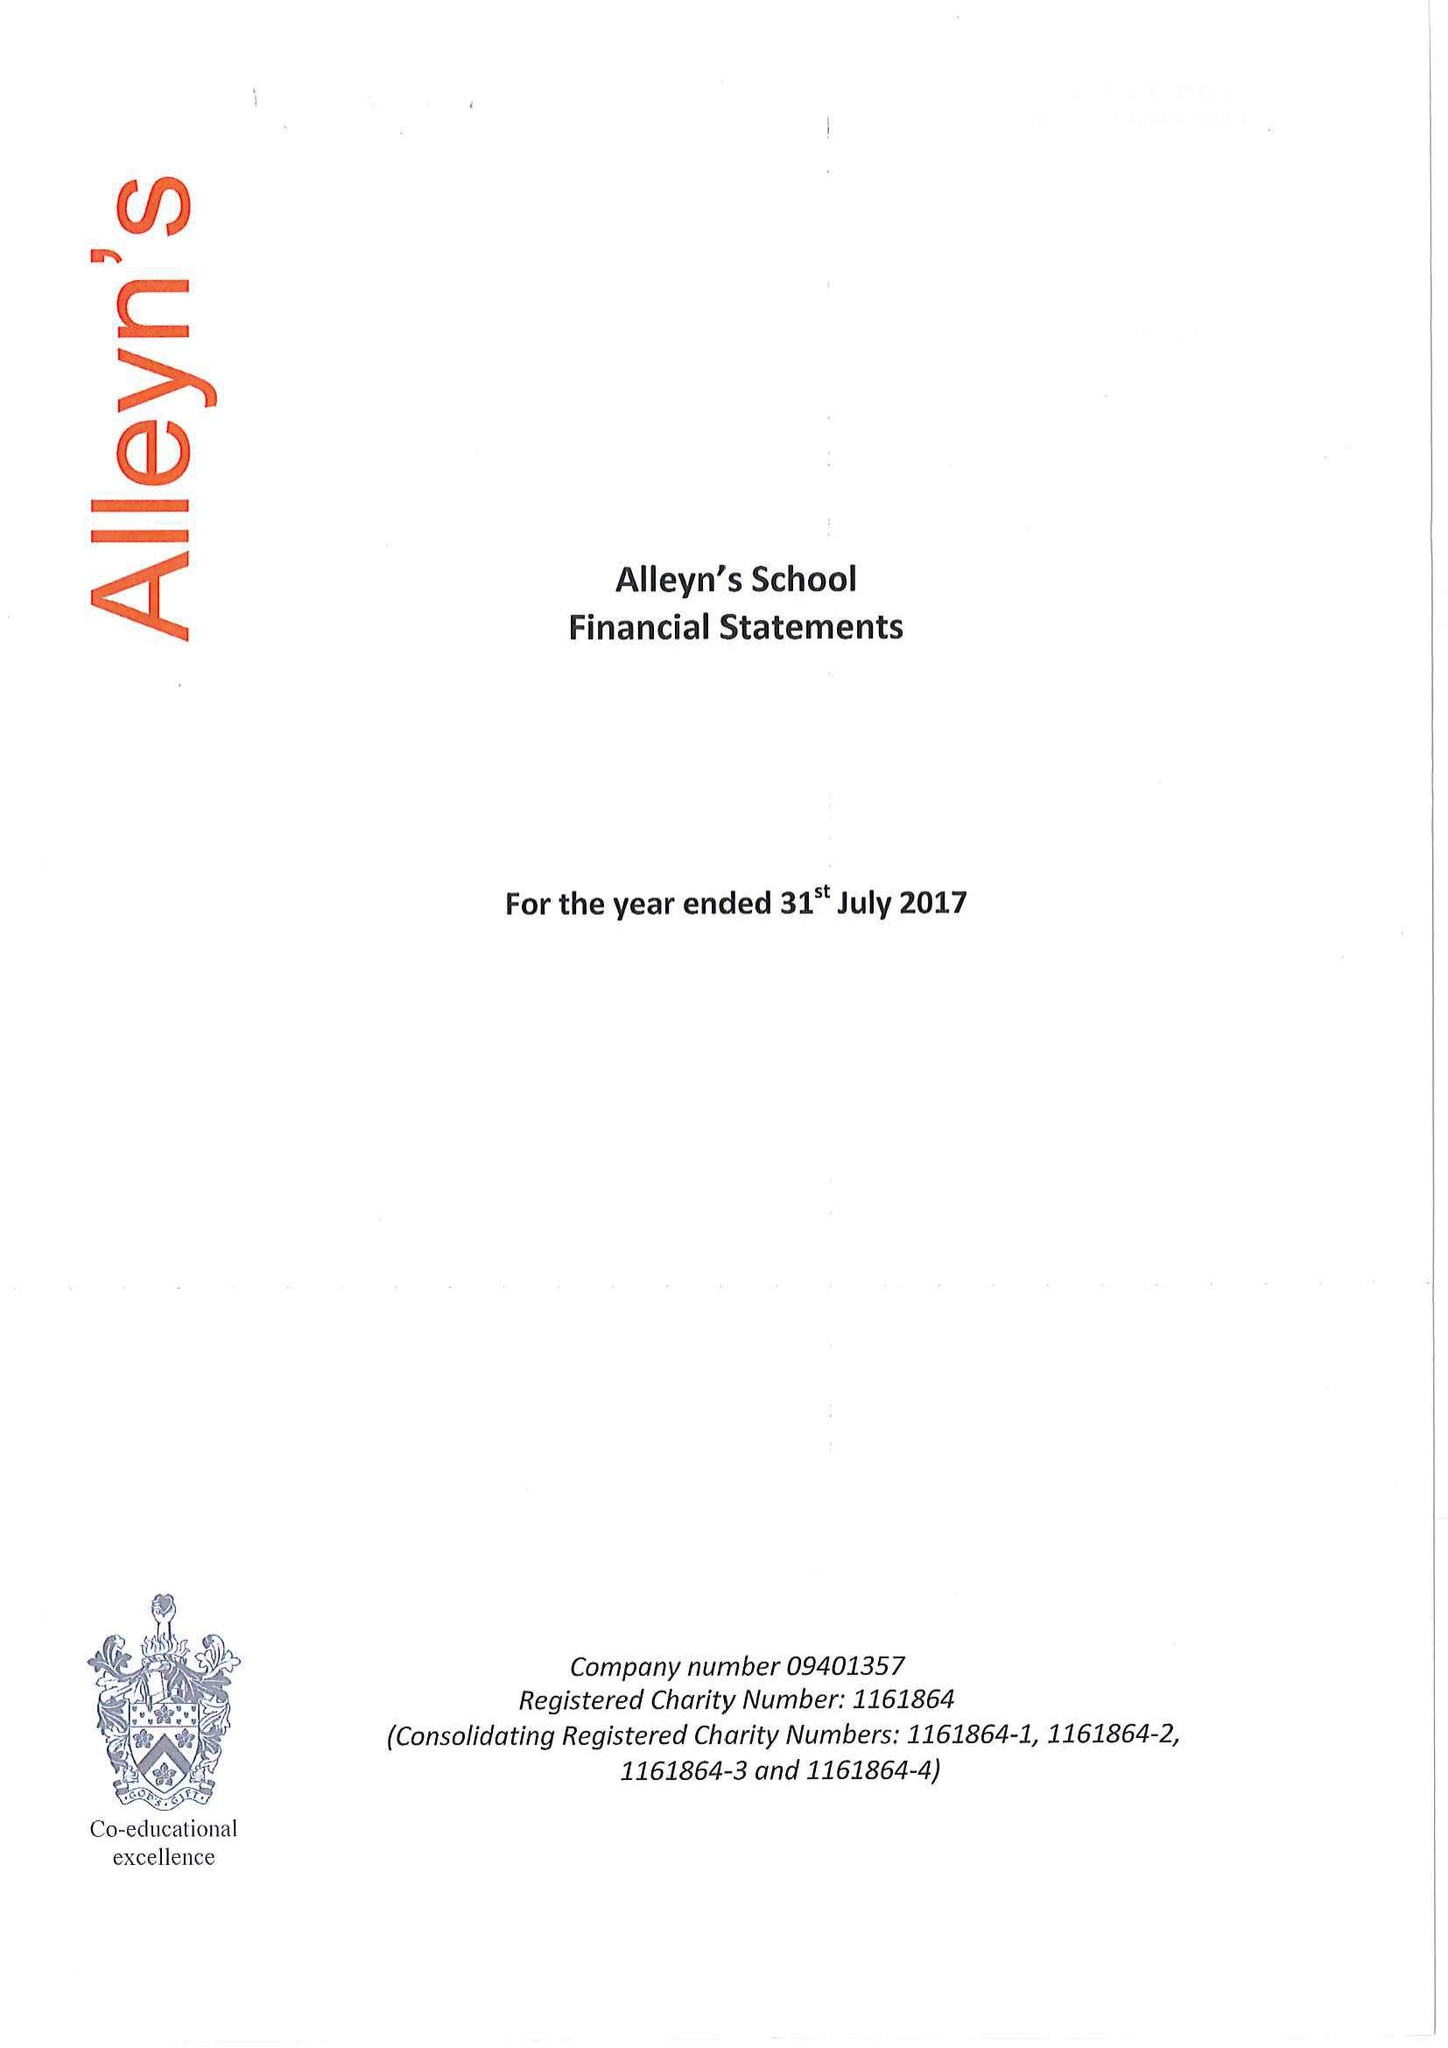What is the value for the income_annually_in_british_pounds?
Answer the question using a single word or phrase. 26240000.00 